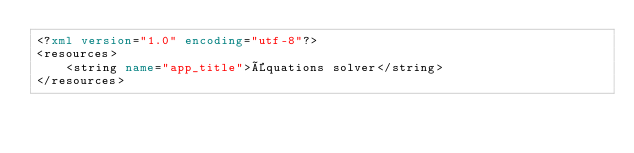<code> <loc_0><loc_0><loc_500><loc_500><_XML_><?xml version="1.0" encoding="utf-8"?>
<resources>
    <string name="app_title">Équations solver</string>
</resources></code> 